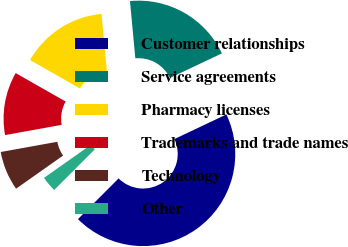<chart> <loc_0><loc_0><loc_500><loc_500><pie_chart><fcel>Customer relationships<fcel>Service agreements<fcel>Pharmacy licenses<fcel>Trademarks and trade names<fcel>Technology<fcel>Other<nl><fcel>44.53%<fcel>19.45%<fcel>15.27%<fcel>11.09%<fcel>6.92%<fcel>2.74%<nl></chart> 